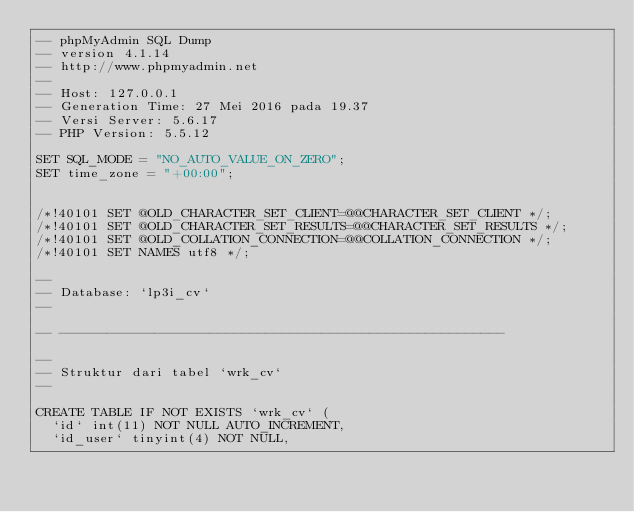<code> <loc_0><loc_0><loc_500><loc_500><_SQL_>-- phpMyAdmin SQL Dump
-- version 4.1.14
-- http://www.phpmyadmin.net
--
-- Host: 127.0.0.1
-- Generation Time: 27 Mei 2016 pada 19.37
-- Versi Server: 5.6.17
-- PHP Version: 5.5.12

SET SQL_MODE = "NO_AUTO_VALUE_ON_ZERO";
SET time_zone = "+00:00";


/*!40101 SET @OLD_CHARACTER_SET_CLIENT=@@CHARACTER_SET_CLIENT */;
/*!40101 SET @OLD_CHARACTER_SET_RESULTS=@@CHARACTER_SET_RESULTS */;
/*!40101 SET @OLD_COLLATION_CONNECTION=@@COLLATION_CONNECTION */;
/*!40101 SET NAMES utf8 */;

--
-- Database: `lp3i_cv`
--

-- --------------------------------------------------------

--
-- Struktur dari tabel `wrk_cv`
--

CREATE TABLE IF NOT EXISTS `wrk_cv` (
  `id` int(11) NOT NULL AUTO_INCREMENT,
  `id_user` tinyint(4) NOT NULL,</code> 